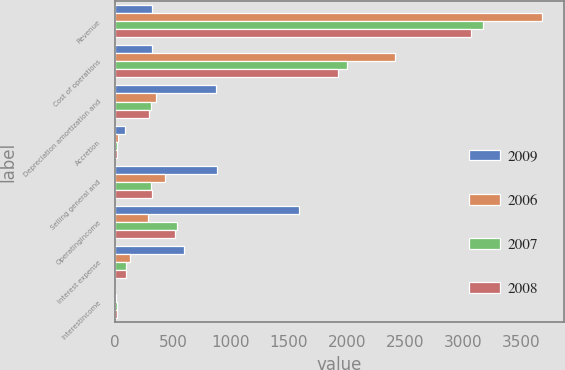<chart> <loc_0><loc_0><loc_500><loc_500><stacked_bar_chart><ecel><fcel>Revenue<fcel>Cost of operations<fcel>Depreciation amortization and<fcel>Accretion<fcel>Selling general and<fcel>Operatingincome<fcel>Interest expense<fcel>Interestincome<nl><fcel>2009<fcel>314.35<fcel>314.35<fcel>869.7<fcel>88.8<fcel>880.4<fcel>1589.8<fcel>595.9<fcel>2<nl><fcel>2006<fcel>3685.1<fcel>2416.7<fcel>354.1<fcel>23.9<fcel>434.7<fcel>283.2<fcel>131.9<fcel>9.6<nl><fcel>2007<fcel>3176.2<fcel>2003.9<fcel>305.5<fcel>17.1<fcel>313.7<fcel>536<fcel>94.8<fcel>12.8<nl><fcel>2008<fcel>3070.6<fcel>1924.4<fcel>296<fcel>15.7<fcel>315<fcel>519.5<fcel>95.8<fcel>15.8<nl></chart> 